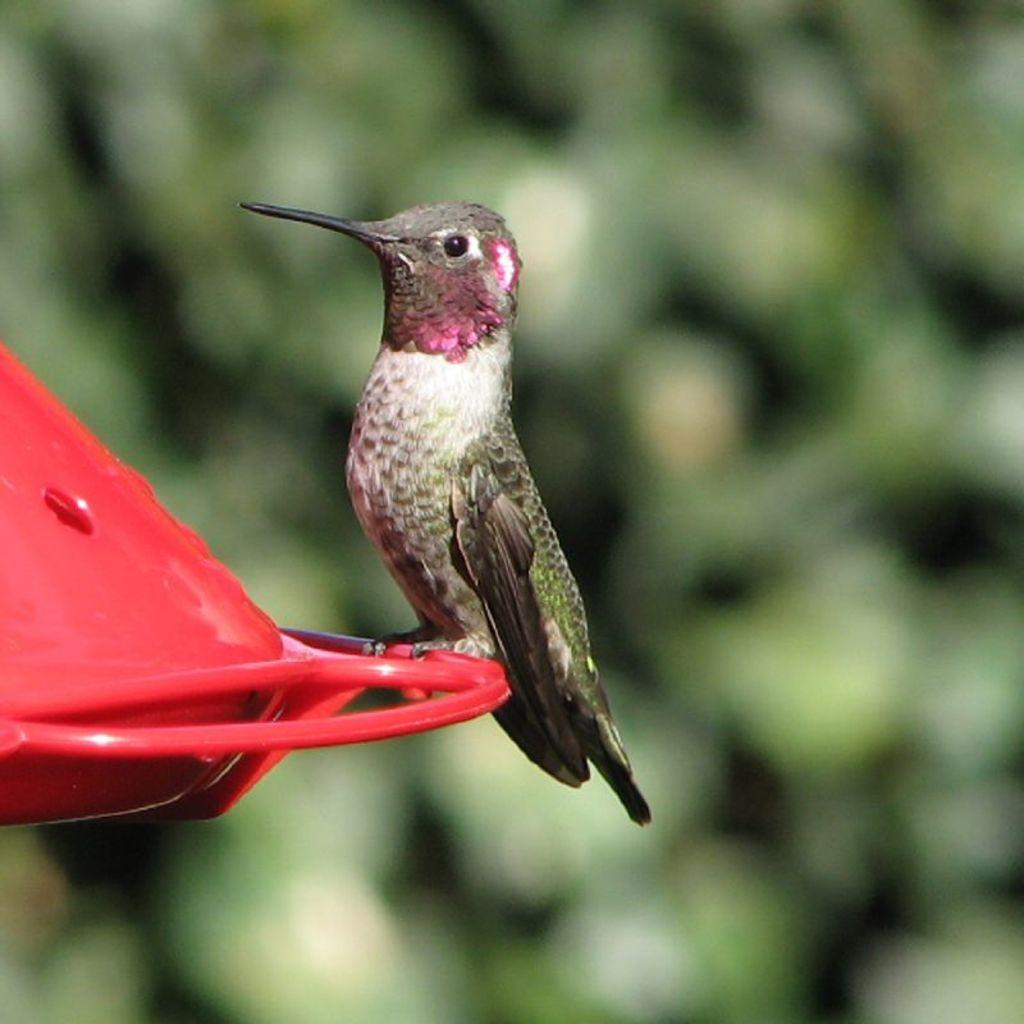What type of animal is in the image? There is a bird in the image. Where is the bird located? The bird is on an object. Can you describe the background of the image? The background of the image is blurry. What type of metal is the bird using to play with the toys in the image? There are no toys or metal present in the image; it only features a bird on an object with a blurry background. 